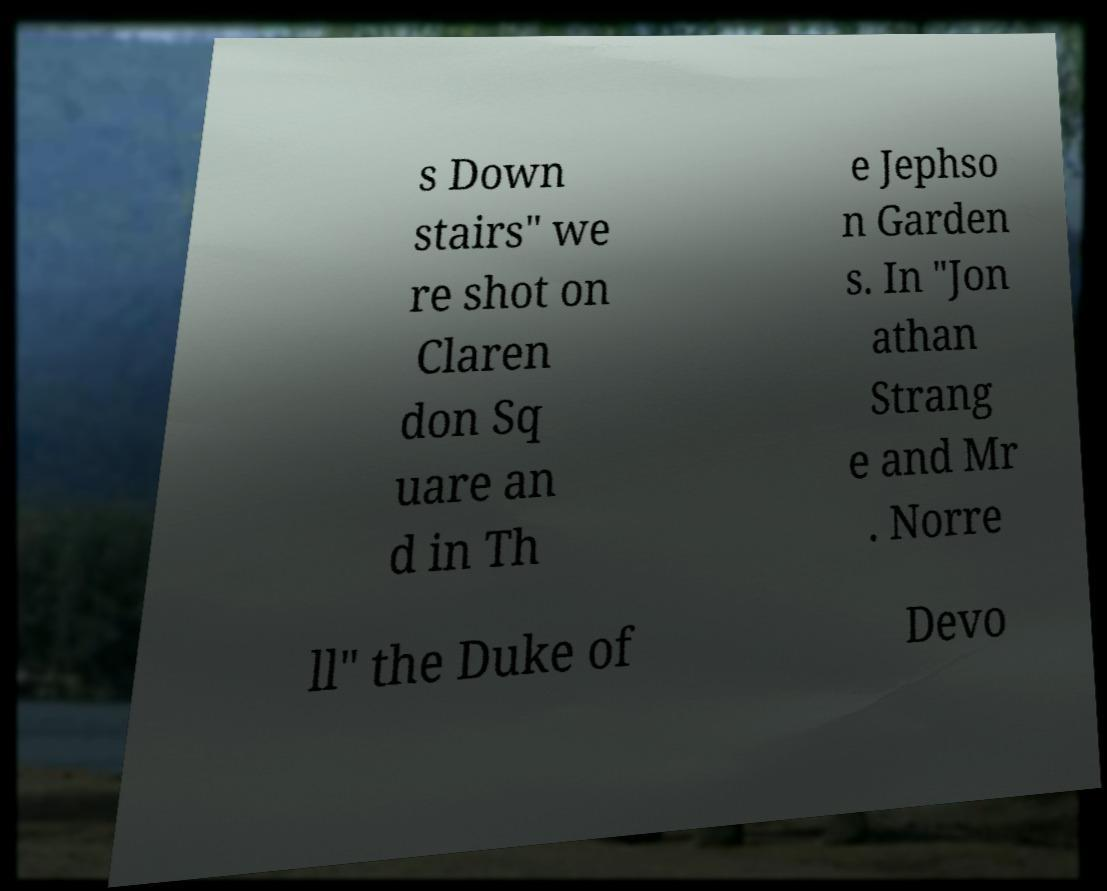What messages or text are displayed in this image? I need them in a readable, typed format. s Down stairs" we re shot on Claren don Sq uare an d in Th e Jephso n Garden s. In "Jon athan Strang e and Mr . Norre ll" the Duke of Devo 